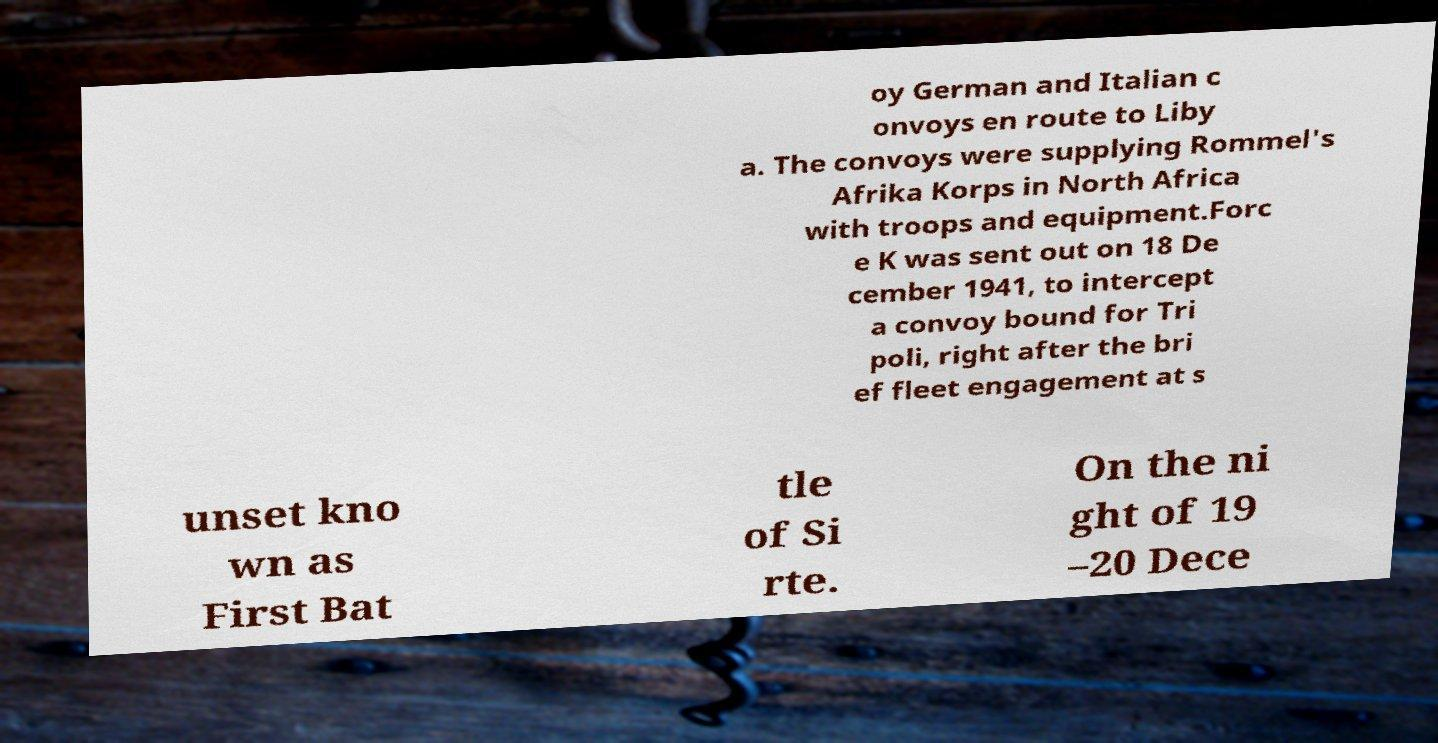Could you extract and type out the text from this image? oy German and Italian c onvoys en route to Liby a. The convoys were supplying Rommel's Afrika Korps in North Africa with troops and equipment.Forc e K was sent out on 18 De cember 1941, to intercept a convoy bound for Tri poli, right after the bri ef fleet engagement at s unset kno wn as First Bat tle of Si rte. On the ni ght of 19 –20 Dece 